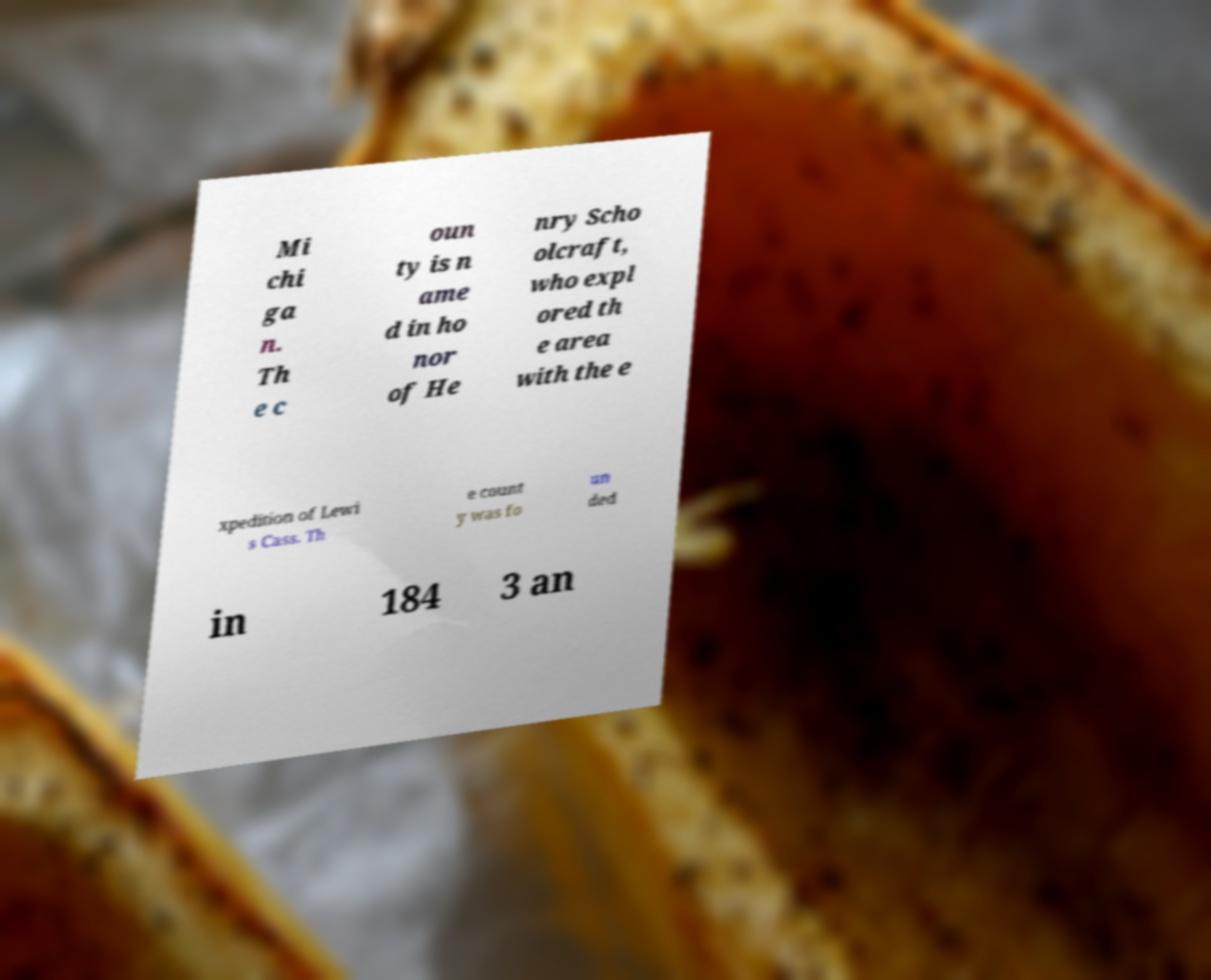Please read and relay the text visible in this image. What does it say? Mi chi ga n. Th e c oun ty is n ame d in ho nor of He nry Scho olcraft, who expl ored th e area with the e xpedition of Lewi s Cass. Th e count y was fo un ded in 184 3 an 